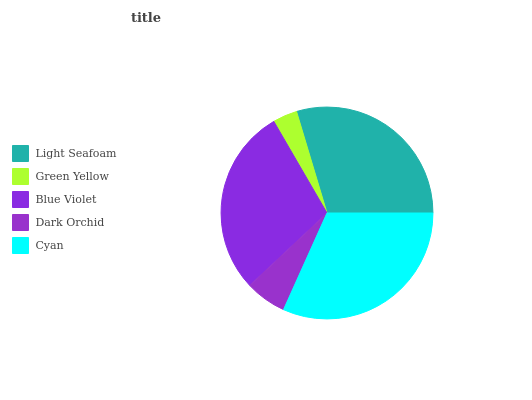Is Green Yellow the minimum?
Answer yes or no. Yes. Is Cyan the maximum?
Answer yes or no. Yes. Is Blue Violet the minimum?
Answer yes or no. No. Is Blue Violet the maximum?
Answer yes or no. No. Is Blue Violet greater than Green Yellow?
Answer yes or no. Yes. Is Green Yellow less than Blue Violet?
Answer yes or no. Yes. Is Green Yellow greater than Blue Violet?
Answer yes or no. No. Is Blue Violet less than Green Yellow?
Answer yes or no. No. Is Blue Violet the high median?
Answer yes or no. Yes. Is Blue Violet the low median?
Answer yes or no. Yes. Is Dark Orchid the high median?
Answer yes or no. No. Is Light Seafoam the low median?
Answer yes or no. No. 